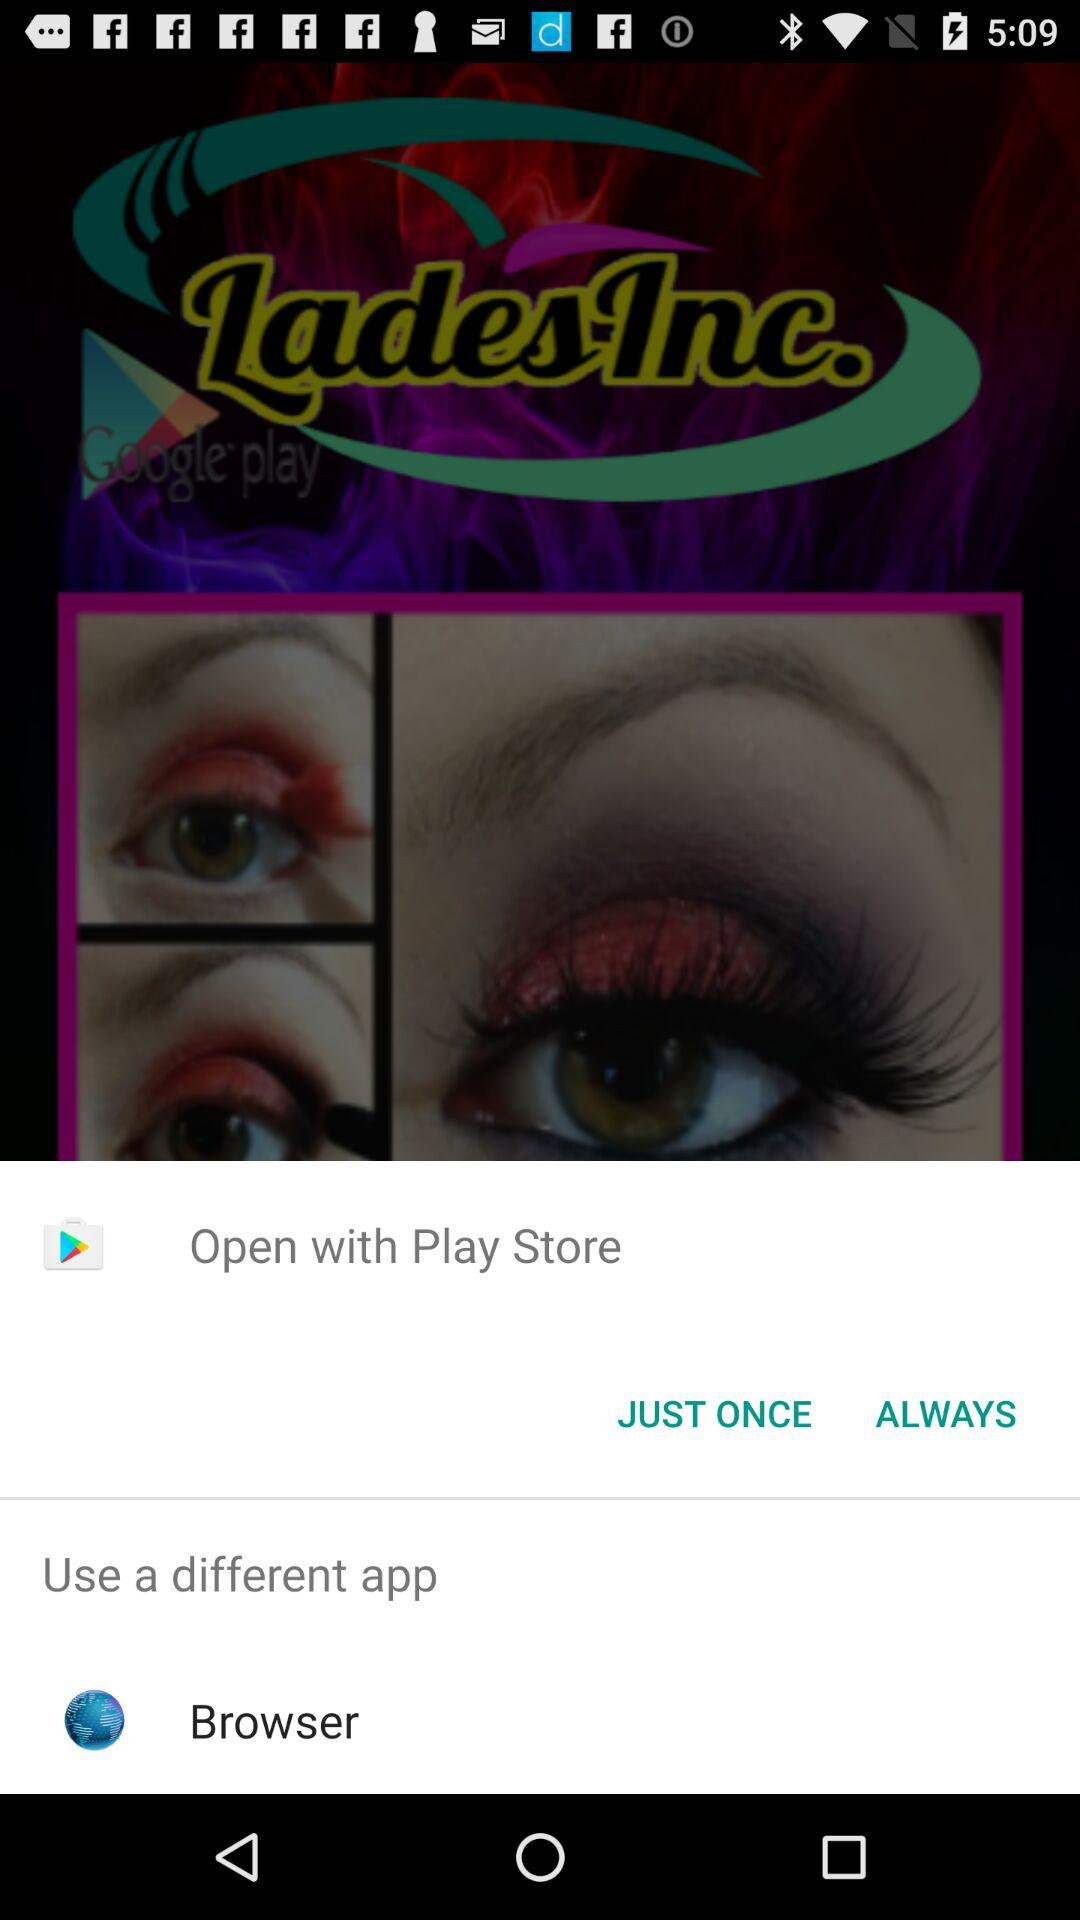Which applications can be used to open with? The applications that can be used to open are "Play Store" and "Browser". 